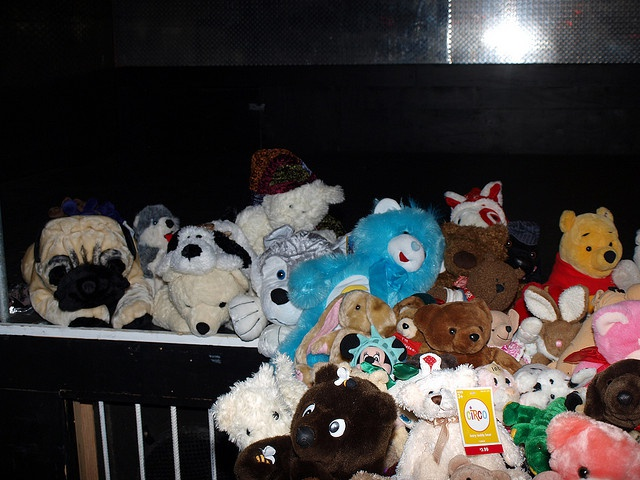Describe the objects in this image and their specific colors. I can see teddy bear in black, maroon, lightgray, and darkgray tones, teddy bear in black, salmon, brown, lightpink, and tan tones, teddy bear in black, teal, and darkgray tones, teddy bear in black, lightgray, darkgray, and tan tones, and teddy bear in black, darkgray, gray, and lightgray tones in this image. 